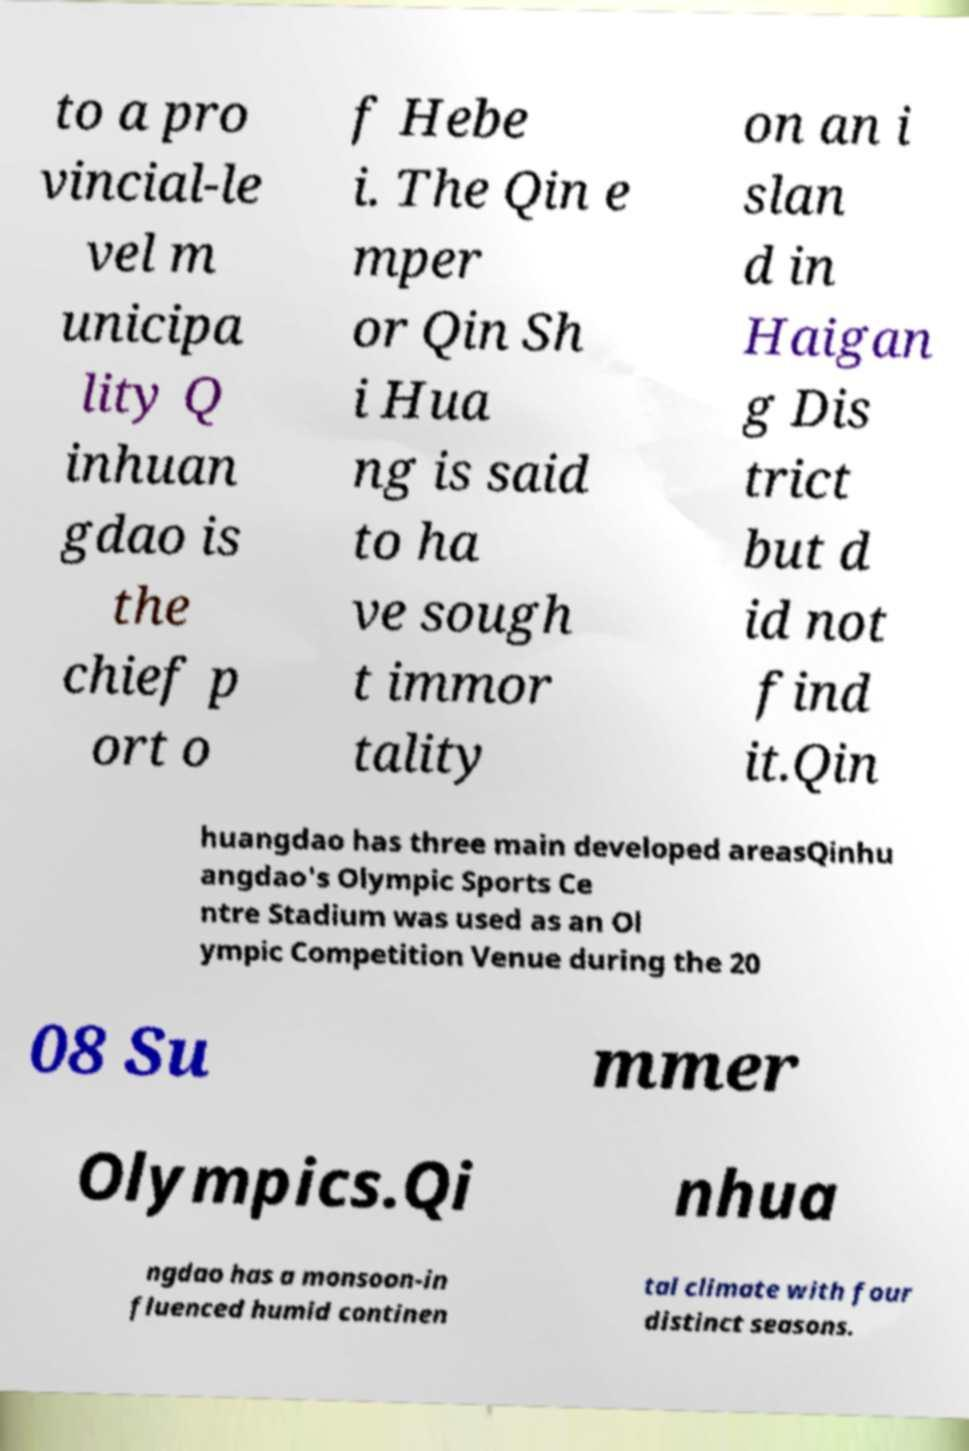What messages or text are displayed in this image? I need them in a readable, typed format. to a pro vincial-le vel m unicipa lity Q inhuan gdao is the chief p ort o f Hebe i. The Qin e mper or Qin Sh i Hua ng is said to ha ve sough t immor tality on an i slan d in Haigan g Dis trict but d id not find it.Qin huangdao has three main developed areasQinhu angdao's Olympic Sports Ce ntre Stadium was used as an Ol ympic Competition Venue during the 20 08 Su mmer Olympics.Qi nhua ngdao has a monsoon-in fluenced humid continen tal climate with four distinct seasons. 